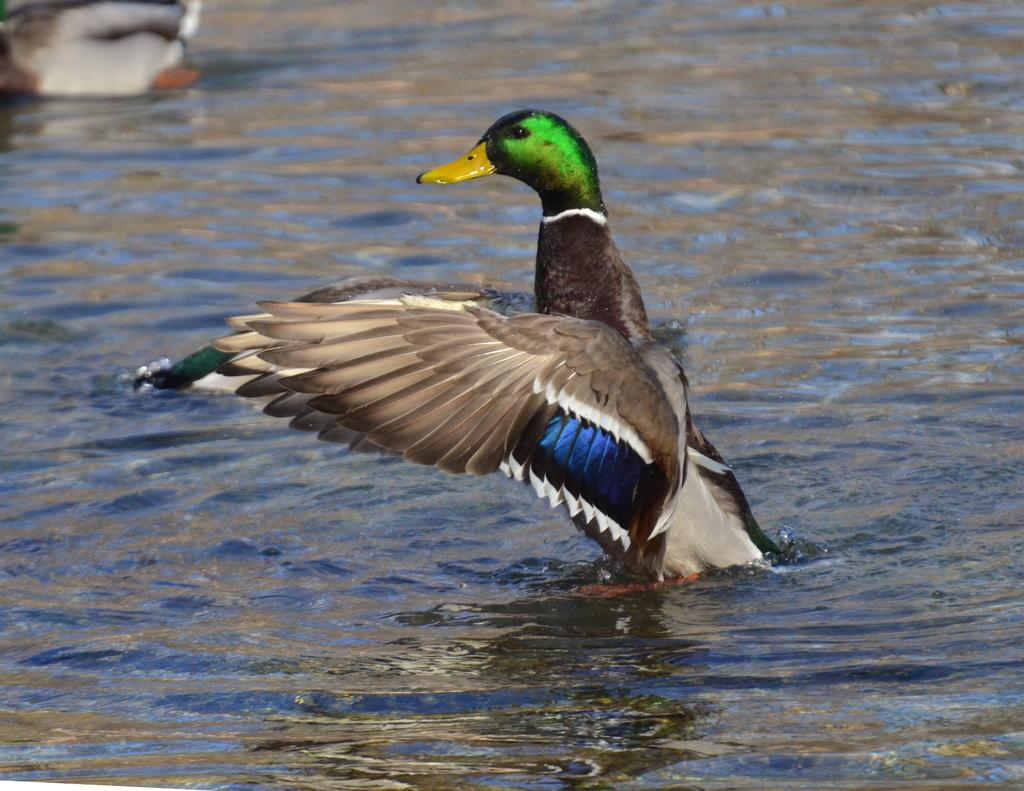What is the main subject of the image? There is a bird in the water. Is there any other bird visible in the image? There may be another bird in the left side top corner of the image, but this is less certain due to the ambiguity in the description. What type of oil can be seen floating on the water in the image? There is no oil visible in the image; it only features a bird in the water. Can you describe the cushion that the bird is sitting on in the image? There is no cushion present in the image; the bird is in the water. 